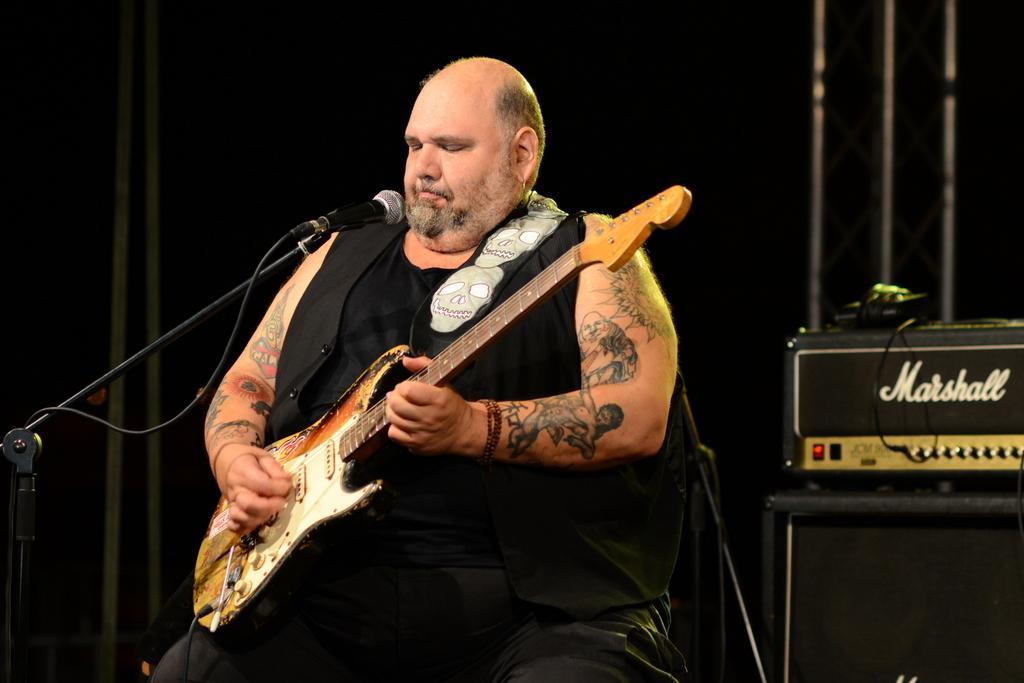Please provide a concise description of this image. In this picture a man is seated on the chair and he is playing guitar in front of microphone, in the background we can see some musical instruments. 